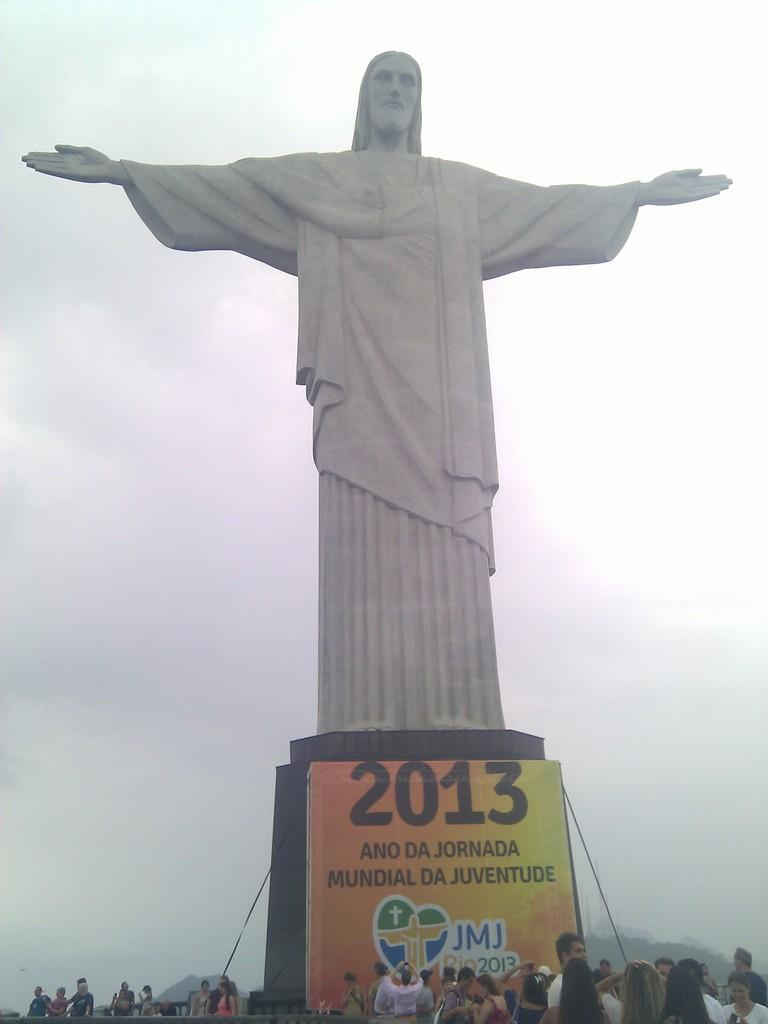<image>
Create a compact narrative representing the image presented. sign for 2013 ano da jornada mundial da juventude underneath statue of jesus with arms widespread 